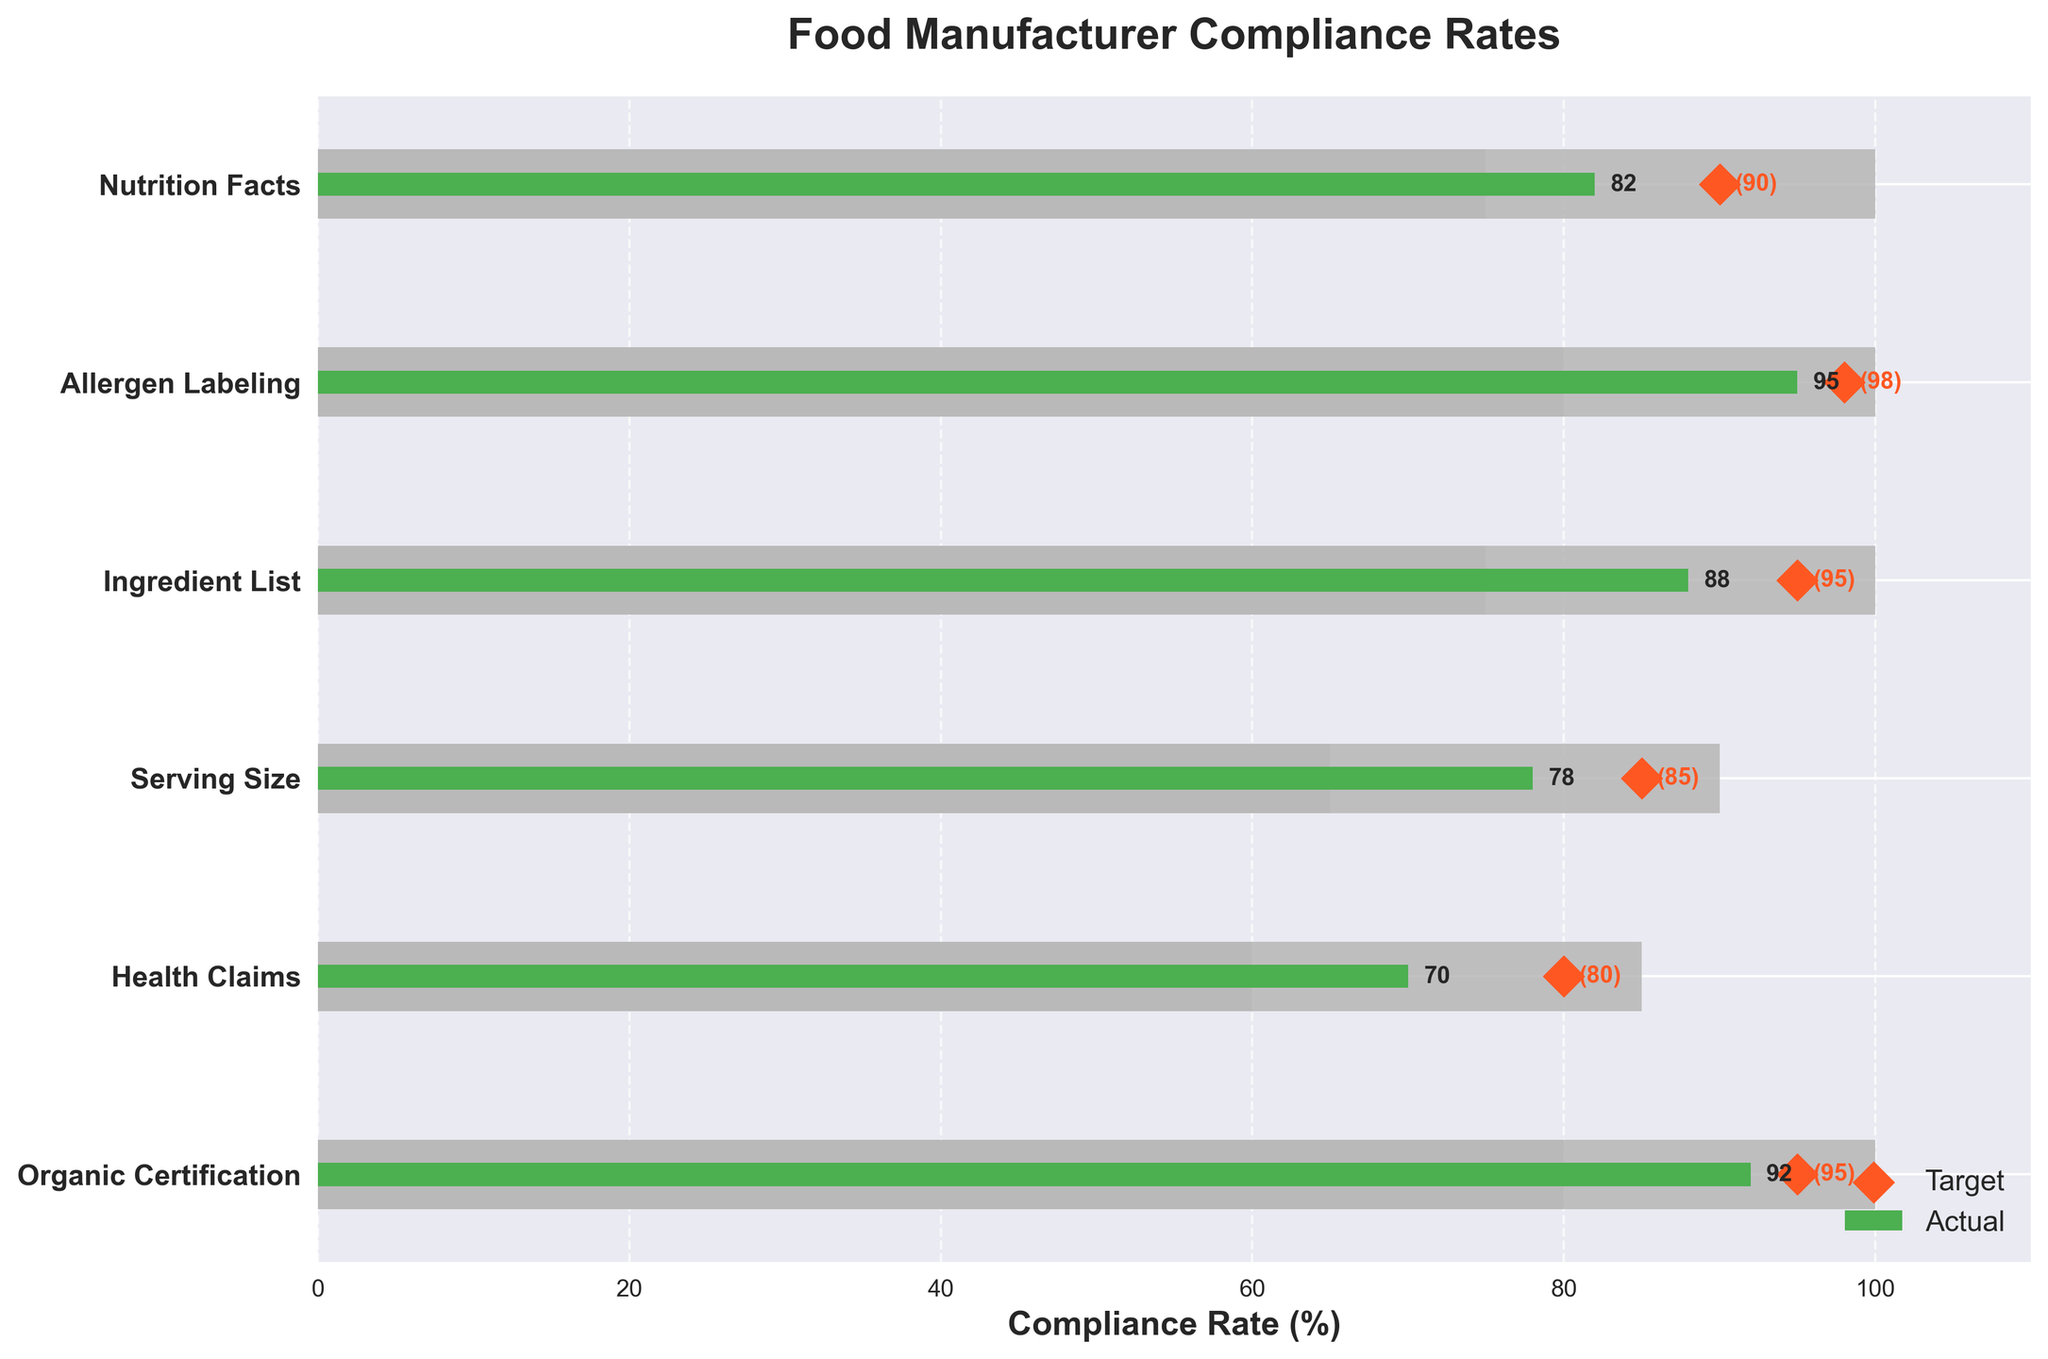What is the title of the figure? The title is usually located at the top of the figure and summarizes the main message. In this plot, the title reads "Food Manufacturer Compliance Rates."
Answer: Food Manufacturer Compliance Rates How many categories are compared in the figure? The categories are listed on the y-axis of the figure. They include Nutrition Facts, Allergen Labeling, Ingredient List, Serving Size, Health Claims, and Organic Certification. Counting them gives us six categories.
Answer: Six Which category has the highest actual compliance rate? Look for the green bar (actual values) that extends the furthest to the right. The Allergen Labeling category has the highest actual compliance rate at 95%.
Answer: Allergen Labeling What is the target compliance rate for Health Claims? In the plot, target compliance rates are represented by orange diamond markers. For Health Claims, the target rate, denoted by an orange diamond, is located at 80%.
Answer: 80% How many categories have an actual compliance rate that meets or exceeds their target compliance rate? Compare the length of each green bar (actual rate) with its corresponding orange diamond marker (target rate). The categories where the green bar meets or exceeds the orange diamond are Allergen Labeling and Organic Certification.
Answer: Two What is the difference between the actual and target compliance rates for Serving Size? Find the actual and target values for Serving Size. The actual rate is 78% and the target rate is 85%. The difference is calculated as 85 - 78.
Answer: 7% Which category has the smallest gap between actual and target compliance rates? Calculate the differences for all categories and compare them. The smallest difference is for Organic Certification, where the actual rate is 92% and the target rate is 95%, giving a gap of 3%.
Answer: Organic Certification What range values are used to categorize compliance for Nutrition Facts? The ranges for Nutrition Facts are indicated by the shaded bars in the background. For Nutrition Facts, these ranges are from 50% to 75%, and from 75% to 100%.
Answer: 50-75, 75-100 How many categories have an actual compliance rate above 80%? Count the green bars (actual rates) that extend beyond the 80% mark. These categories are Nutrition Facts, Allergen Labeling, Ingredient List, and Organic Certification
Answer: Four Which category has the lowest actual compliance rate and by how much does it fall short of its target? Identify the category with the shortest green bar (lowest actual rate). Health Claims has the lowest actual compliance rate at 70%, with a target of 80%. The shortfall is 80 - 70.
Answer: Health Claims, 10 